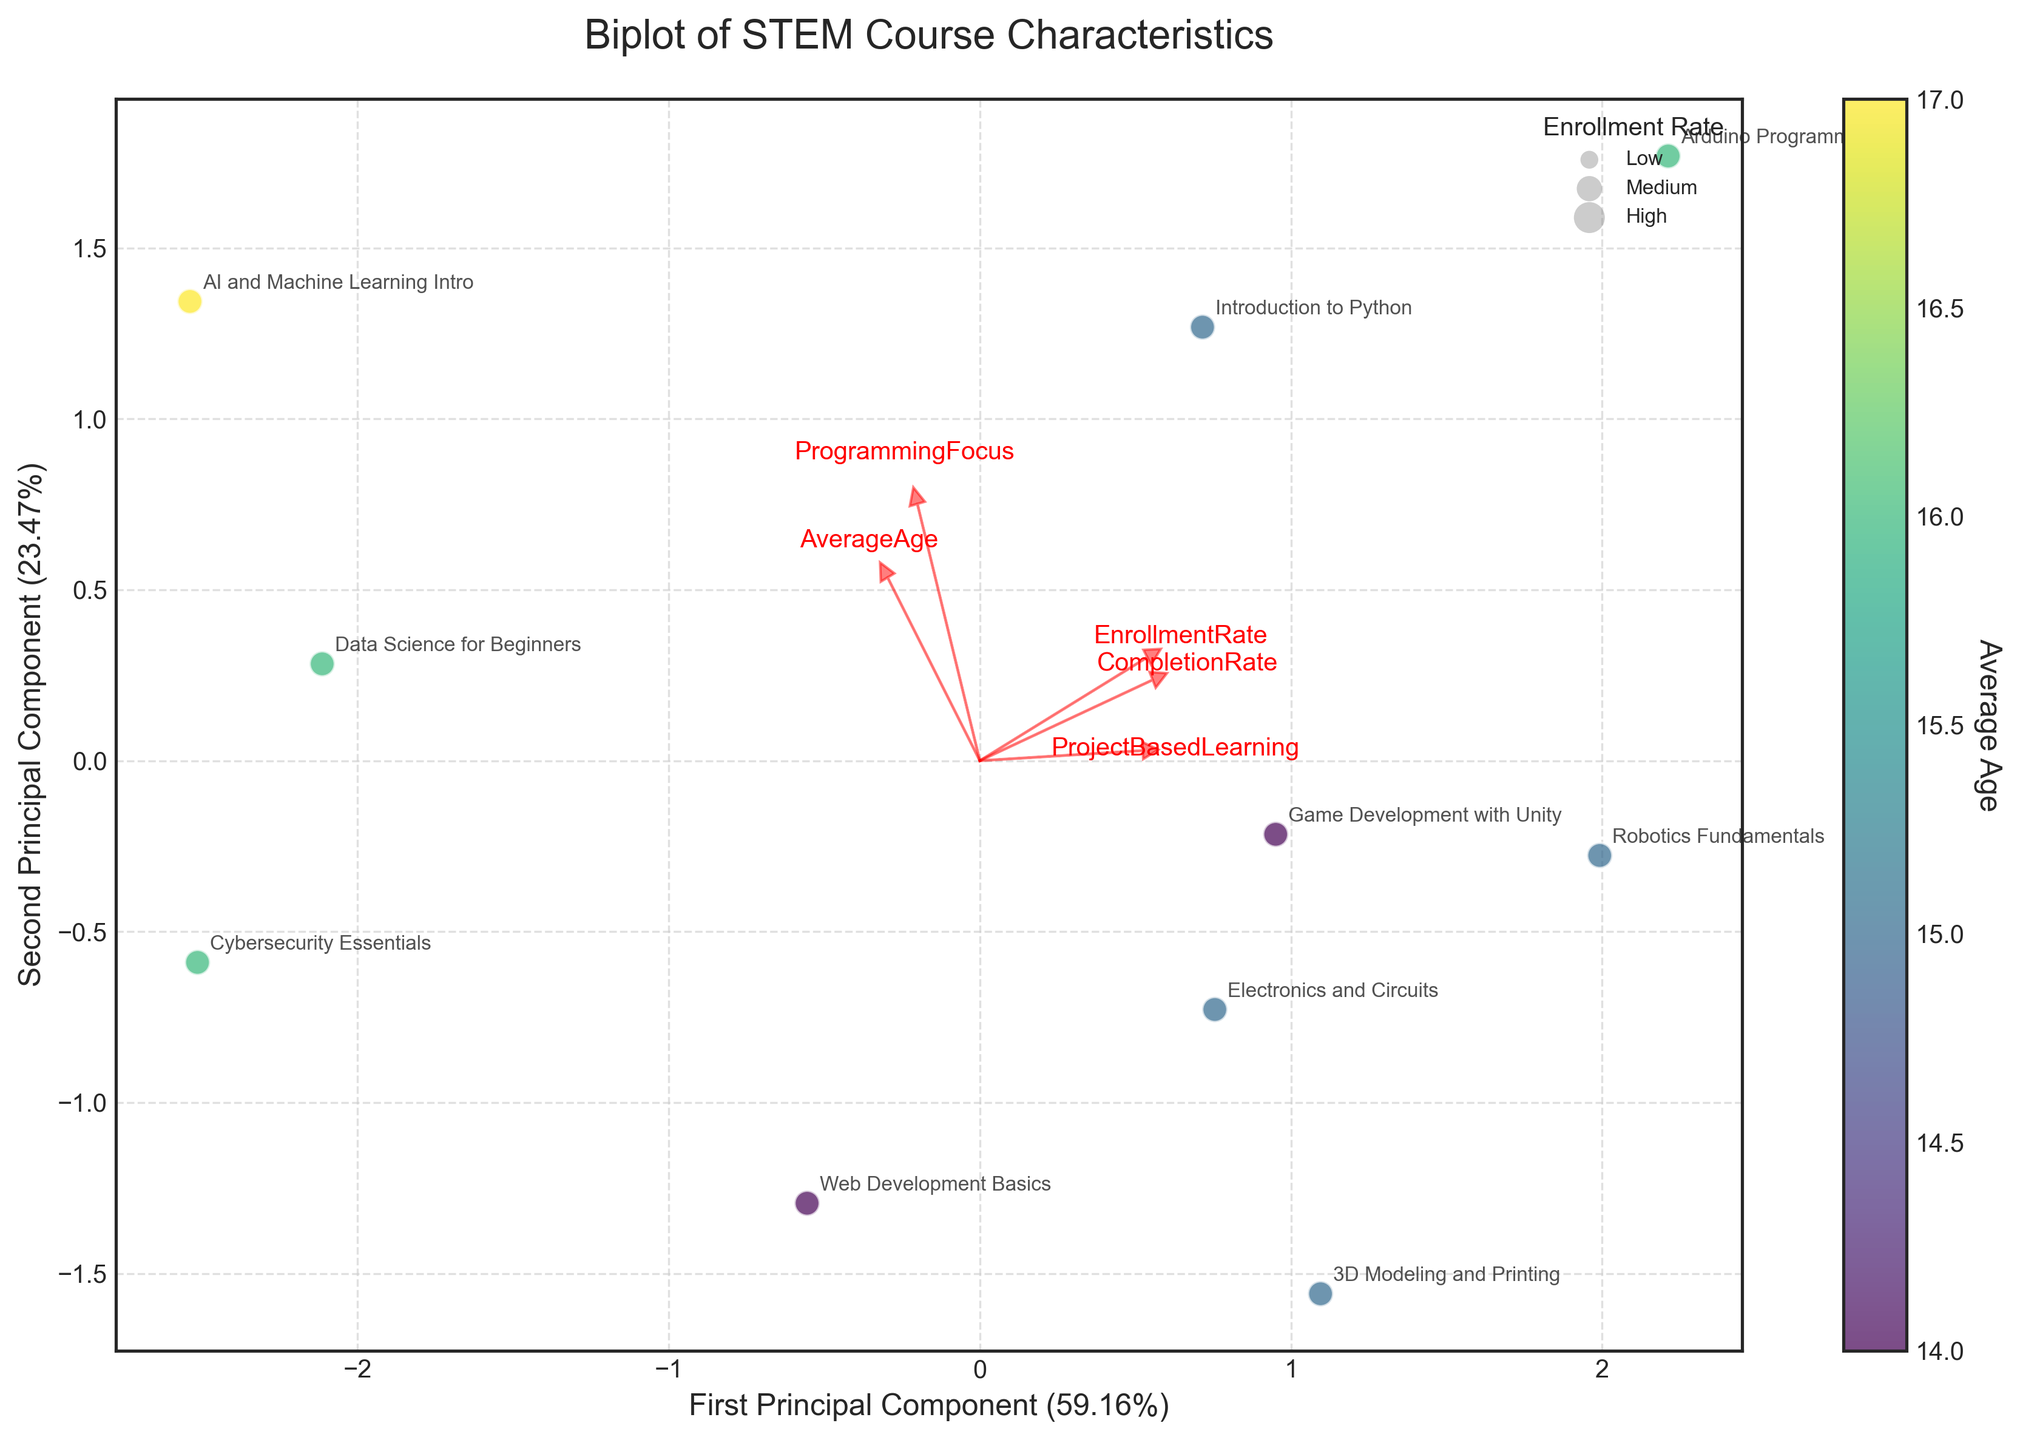What's the title of the plot? The plot has a title shown at the top, which is "Biplot of STEM Course Characteristics".
Answer: Biplot of STEM Course Characteristics How many principal components are shown on the axes? The x-axis and y-axis each represent one principal component.
Answer: 2 Which course has the highest Enrollment Rate? Look for the course at the point with highest Enrollment Rate value in the plotted legend for enrollment rate sizes and labels.
Answer: Arduino Programming Which course is most closely associated with Project-Based Learning? Look for the course positioned closest to the arrow labeled "ProjectBasedLearning", which is a vector in the positive second quadrant.
Answer: Arduino Programming What is the general relationship between CompletionRate and ProjectBasedLearning? CompletionRate and ProjectBasedLearning have arrows oriented in a similar direction, indicating a positive association between them.
Answer: Positive association Which course has an average age of 17? The colorbar represents average age, and the course nearest to the darkest purple point indicating 17 is "AI and Machine Learning Intro".
Answer: AI and Machine Learning Intro Compare the Enrollment Rate of "Electronics and Circuits" and "Data Science for Beginners". Which has a higher rate? Look for the positions of the points for both courses and compare their relative sizes in the enrollment rate legend.
Answer: Electronics and Circuits Which principal component explains more variance in the data? Check the x-axis and y-axis labels for the percentage explained by each principal component; the one with the higher percentage is the one explaining more variance.
Answer: First Principal Component What is the approximate variance explained by the second principal component? The label on the y-axis indicates the variance explained by the second principal component in percentage terms.
Answer: About 28% What general observation can be made about courses with lower completion rates and their position relative to AverageAge? Courses with lower completion rates tend to be associated with slightly higher average ages based on their position and color gradient.
Answer: Older students What's the correlation between AverageAge and ProgrammingFocus? By looking at the arrows' orientation and their closeness, the arrows of AverageAge and ProgrammingFocus generally point in the same direction, indicating a positive correlation.
Answer: Positive correlation 